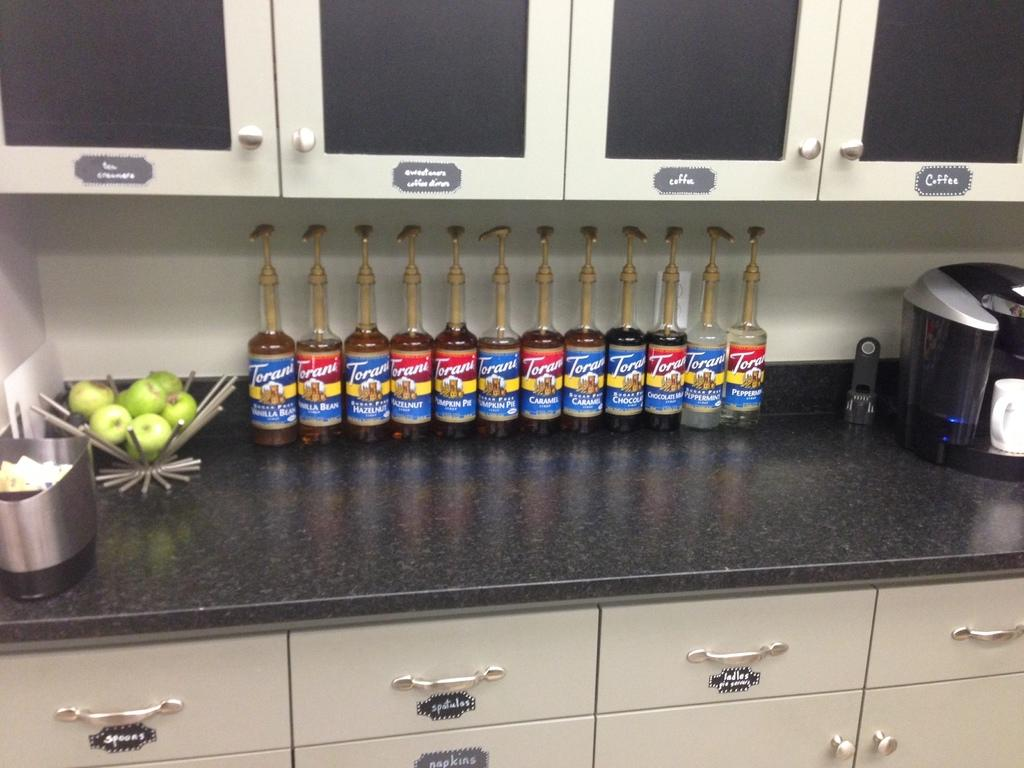What surface is visible in the image? There is a kitchen counter top in the image. What items can be seen on the counter top? There are fruits, bottles, and a coffee maker on the counter top. Are there any other objects on the counter top? Yes, there are other objects on the counter top. What type of storage units are present in the image? There are cupboards and drawers in the image. What type of zinc object can be seen on the counter top in the image? There is no zinc object present on the counter top in the image. Can you read the letter that is lying on the counter top in the image? There is no letter present on the counter top in the image. 